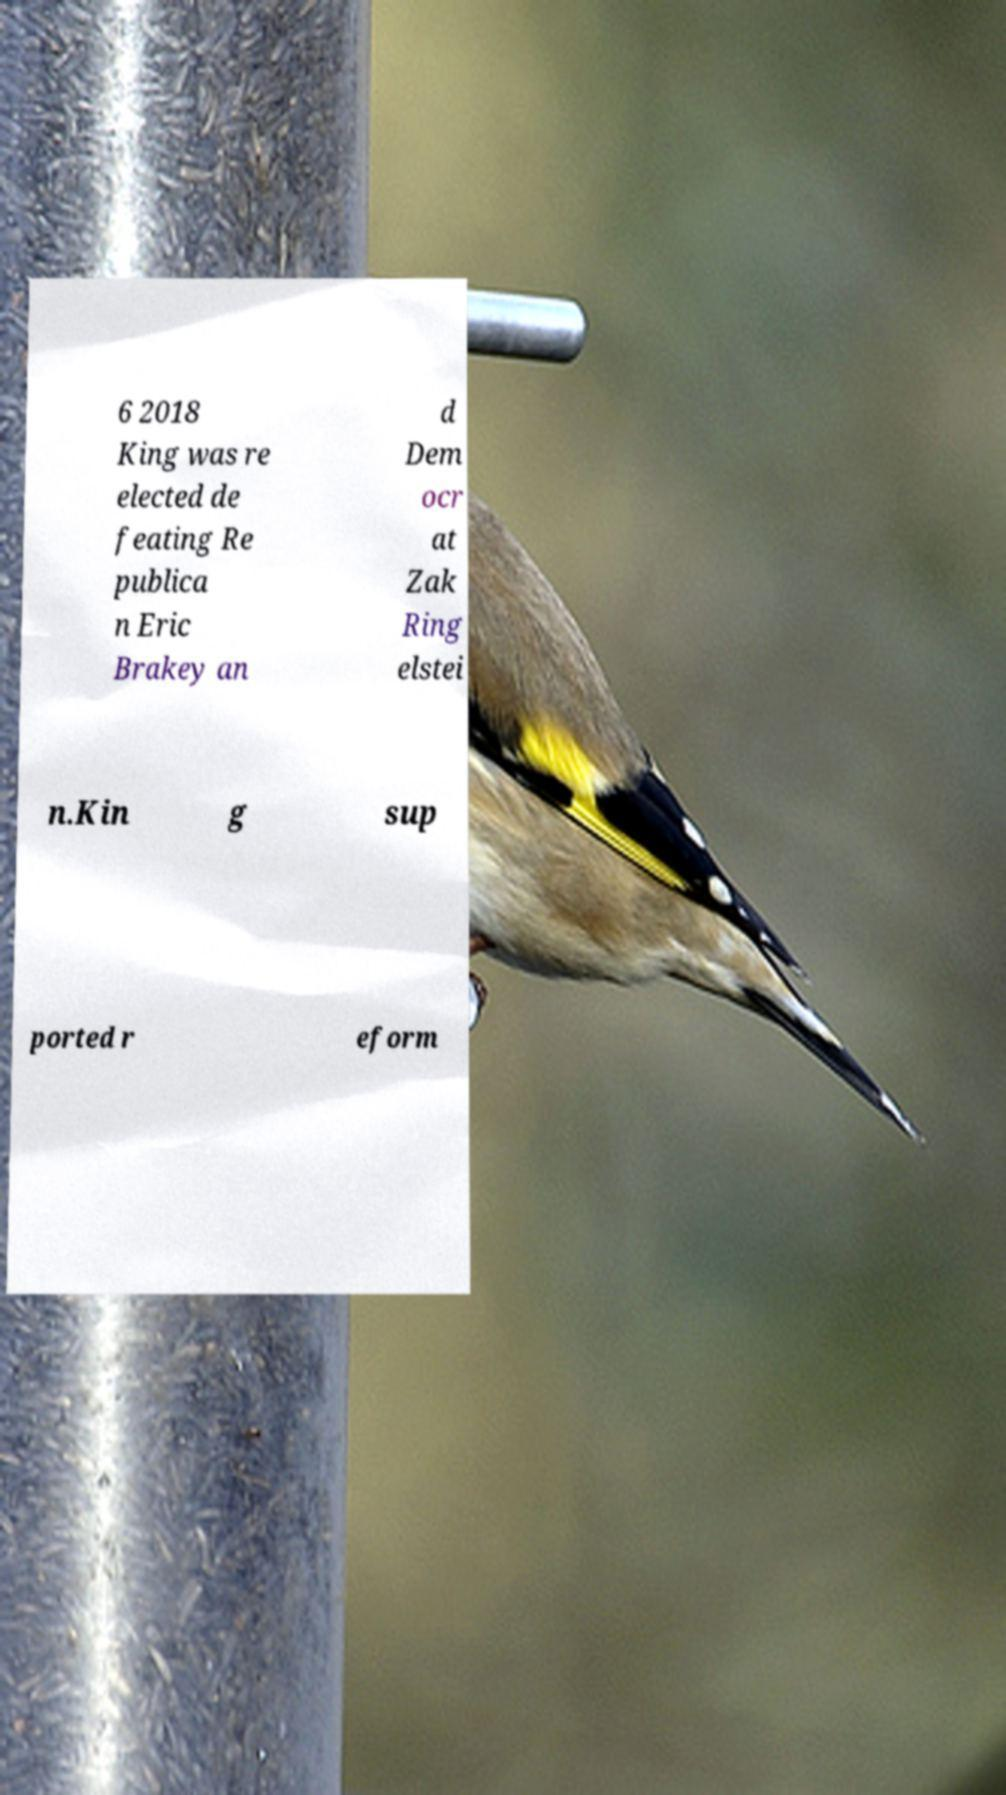Can you accurately transcribe the text from the provided image for me? 6 2018 King was re elected de feating Re publica n Eric Brakey an d Dem ocr at Zak Ring elstei n.Kin g sup ported r eform 